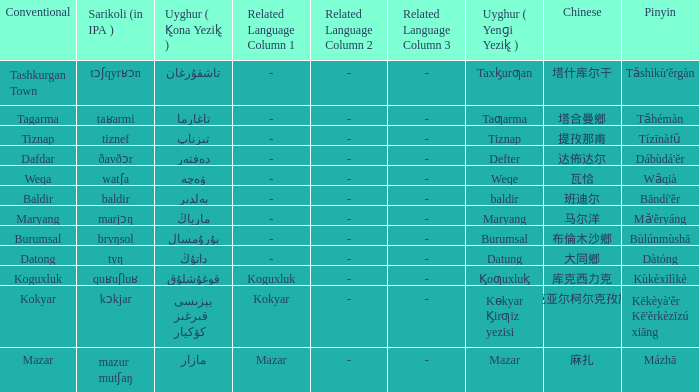Name the conventional for تاغارما Tagarma. 